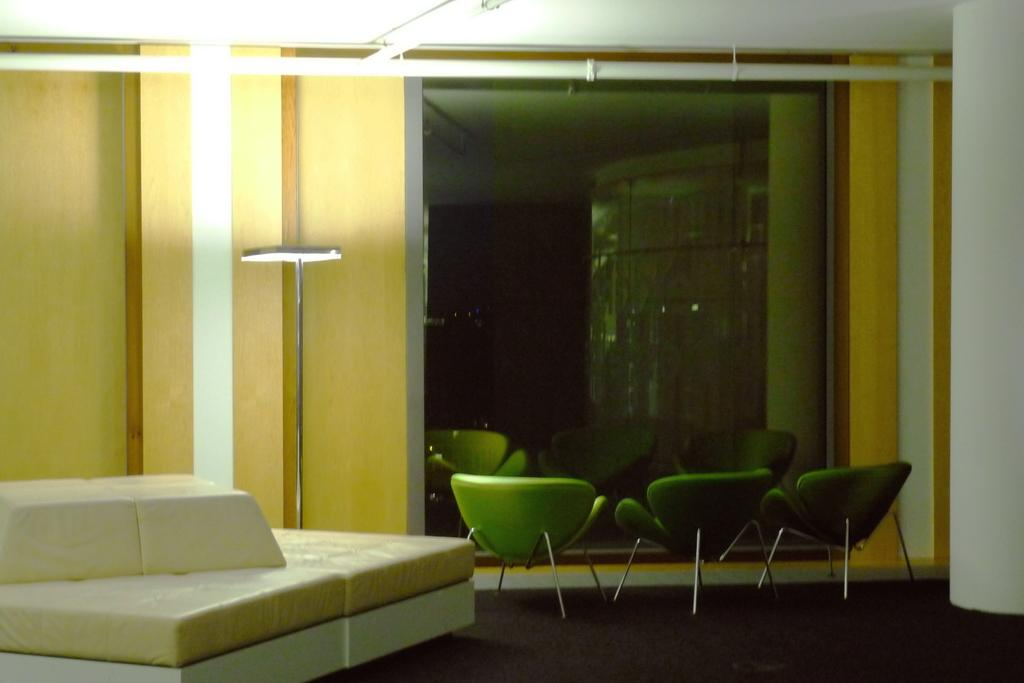Where is the image taken? The image is taken in a room. What can be seen in the middle of the room? There are three empty chairs in the middle of the room. What is a feature of the room that allows natural light to enter? There is a window in the room. What provides artificial light in the room? There is a light in the room. What is located on the left side of the room? There is a bed and a wall on the left side of the room. How many ladybugs can be seen on the bed in the image? There are no ladybugs present in the image; it only shows an empty bed and a wall on the left side of the room. 